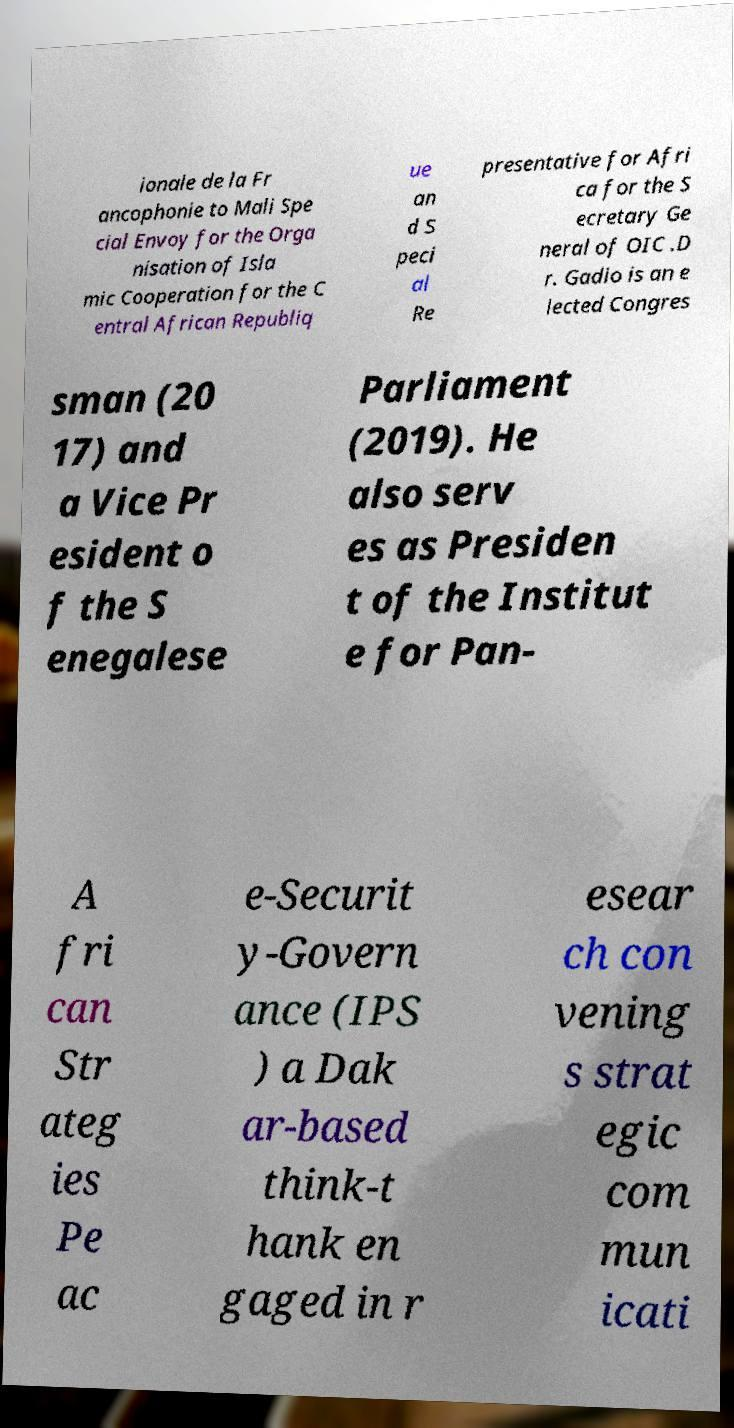What messages or text are displayed in this image? I need them in a readable, typed format. ionale de la Fr ancophonie to Mali Spe cial Envoy for the Orga nisation of Isla mic Cooperation for the C entral African Republiq ue an d S peci al Re presentative for Afri ca for the S ecretary Ge neral of OIC .D r. Gadio is an e lected Congres sman (20 17) and a Vice Pr esident o f the S enegalese Parliament (2019). He also serv es as Presiden t of the Institut e for Pan- A fri can Str ateg ies Pe ac e-Securit y-Govern ance (IPS ) a Dak ar-based think-t hank en gaged in r esear ch con vening s strat egic com mun icati 